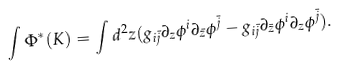<formula> <loc_0><loc_0><loc_500><loc_500>\int \Phi ^ { * } ( K ) = \int d ^ { 2 } z ( g _ { i \bar { j } } \partial _ { z } \phi ^ { i } \partial _ { \bar { z } } \phi ^ { \bar { j } } - g _ { i \bar { j } } \partial _ { \bar { z } } \phi ^ { i } \partial _ { z } \phi ^ { \bar { j } } ) .</formula> 